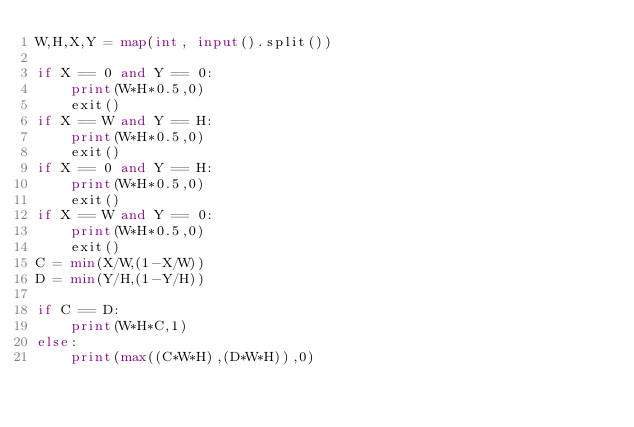<code> <loc_0><loc_0><loc_500><loc_500><_Python_>W,H,X,Y = map(int, input().split())

if X == 0 and Y == 0:
    print(W*H*0.5,0)
    exit()
if X == W and Y == H:
    print(W*H*0.5,0)
    exit()
if X == 0 and Y == H:
    print(W*H*0.5,0)
    exit()
if X == W and Y == 0:
    print(W*H*0.5,0)
    exit()
C = min(X/W,(1-X/W))
D = min(Y/H,(1-Y/H))

if C == D:
    print(W*H*C,1)
else:
    print(max((C*W*H),(D*W*H)),0)</code> 